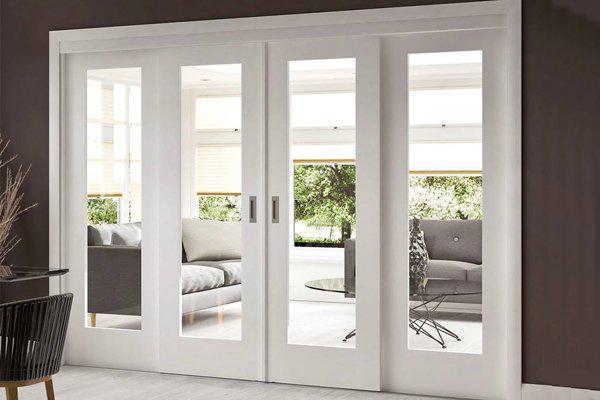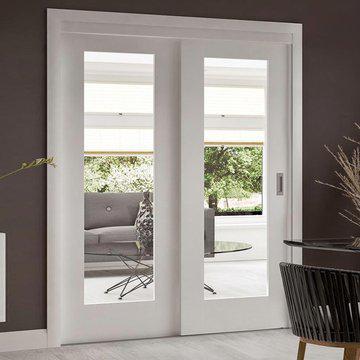The first image is the image on the left, the second image is the image on the right. Evaluate the accuracy of this statement regarding the images: "Each image shows equal sized white double sliding doors with decorative panels, with one door with visible hardware partially opened.". Is it true? Answer yes or no. No. The first image is the image on the left, the second image is the image on the right. Analyze the images presented: Is the assertion "An image shows a white-framed sliding door partly opened on the right, revealing a square framed item on the wall." valid? Answer yes or no. No. 